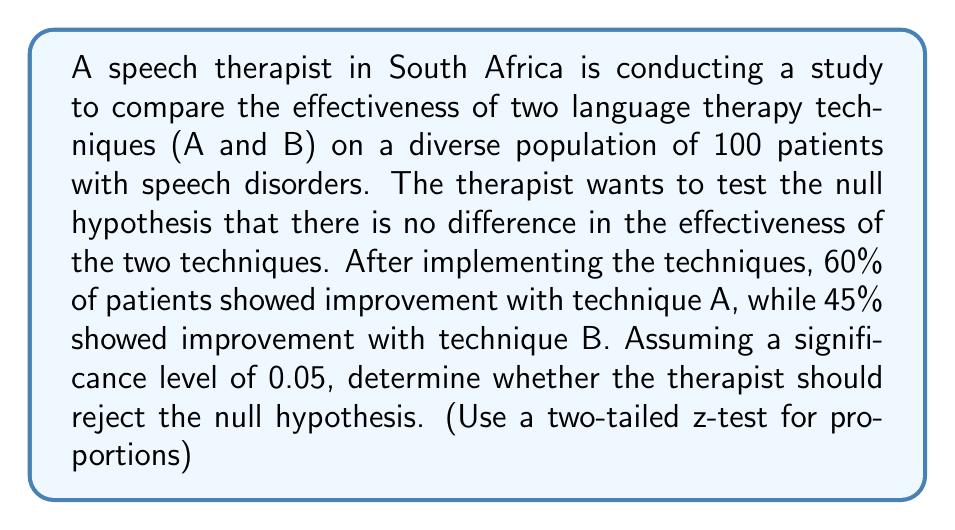Help me with this question. Let's approach this step-by-step:

1) Define the null and alternative hypotheses:
   $H_0: p_A - p_B = 0$
   $H_a: p_A - p_B \neq 0$

2) Calculate the pooled proportion:
   $$\hat{p} = \frac{n_A\hat{p}_A + n_B\hat{p}_B}{n_A + n_B} = \frac{50(0.60) + 50(0.45)}{100} = 0.525$$

3) Calculate the standard error:
   $$SE = \sqrt{\hat{p}(1-\hat{p})(\frac{1}{n_A} + \frac{1}{n_B})} = \sqrt{0.525(0.475)(\frac{1}{50} + \frac{1}{50})} = 0.0997$$

4) Calculate the z-statistic:
   $$z = \frac{(\hat{p}_A - \hat{p}_B) - 0}{SE} = \frac{0.60 - 0.45}{0.0997} = 1.505$$

5) Find the critical z-value for a two-tailed test at α = 0.05:
   $z_{critical} = \pm 1.96$

6) Compare the calculated z-statistic to the critical value:
   $|1.505| < 1.96$

7) Calculate the p-value:
   $p-value = 2 * P(Z > 1.505) \approx 0.1324$

Since $|z| < z_{critical}$ and $p-value > 0.05$, we fail to reject the null hypothesis.
Answer: Fail to reject the null hypothesis 